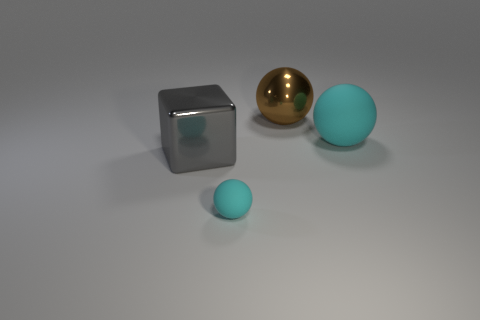Subtract all big brown balls. How many balls are left? 2 Add 2 large rubber objects. How many objects exist? 6 Subtract all brown balls. How many balls are left? 2 Subtract 1 blocks. How many blocks are left? 0 Subtract all red blocks. Subtract all cyan spheres. How many blocks are left? 1 Subtract all green blocks. How many brown spheres are left? 1 Subtract all large brown matte cubes. Subtract all large matte spheres. How many objects are left? 3 Add 4 brown shiny balls. How many brown shiny balls are left? 5 Add 3 cyan objects. How many cyan objects exist? 5 Subtract 0 yellow spheres. How many objects are left? 4 